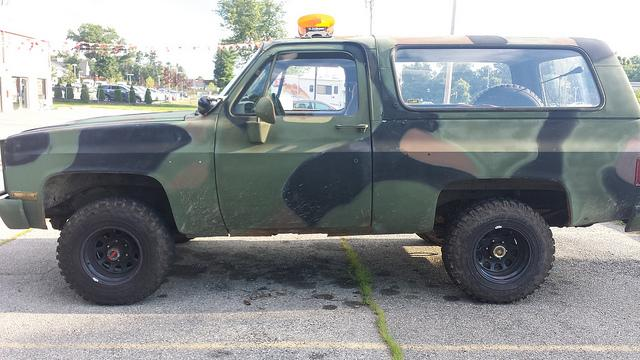What style of paint is on this vehicle? camo 